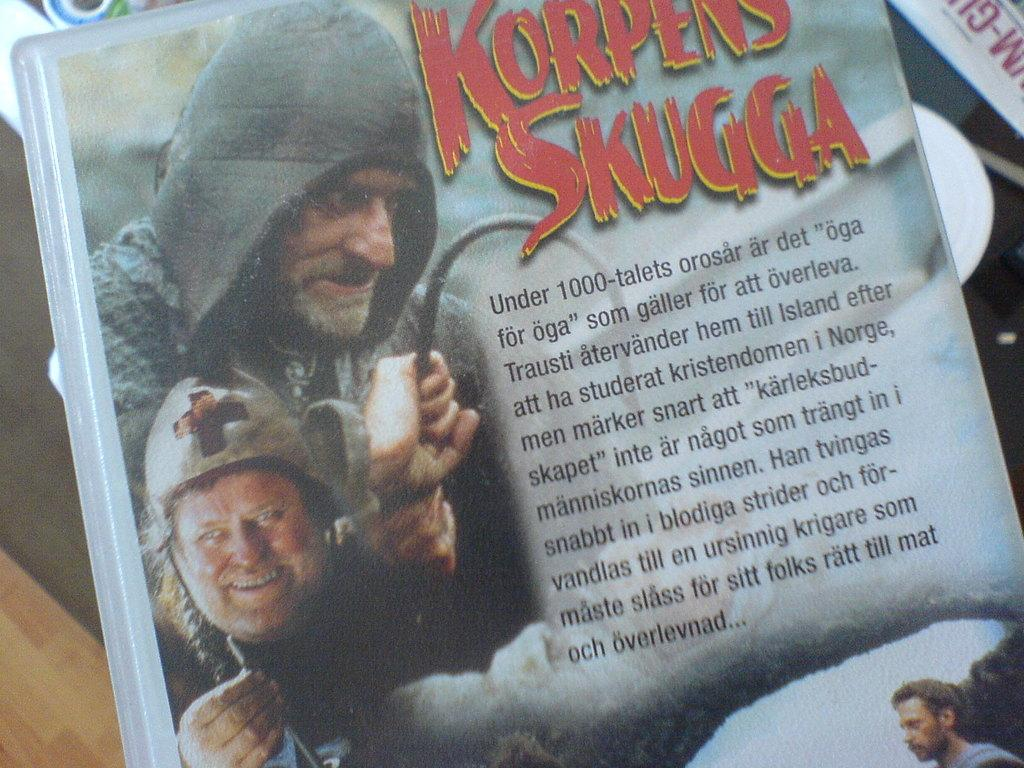What object can be seen in the image? There is a book in the image. What type of surface is visible in the background of the image? There is a floor visible in the background of the image. What type of waves can be seen in the image? There are no waves present in the image; it features a book and a floor. What is the current state of the book in the image? The book appears to be stationary in the image, so it is not possible to determine its current state. 